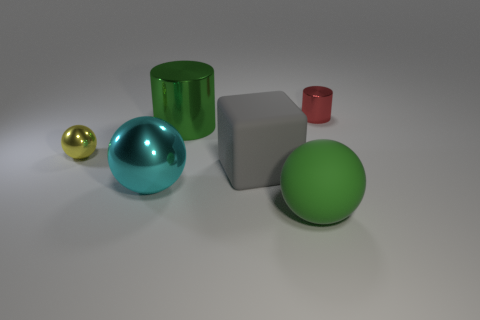Add 3 big cyan metal things. How many objects exist? 9 Subtract all cubes. How many objects are left? 5 Subtract all yellow metal cylinders. Subtract all big cyan metal balls. How many objects are left? 5 Add 4 blocks. How many blocks are left? 5 Add 6 large brown things. How many large brown things exist? 6 Subtract 0 gray spheres. How many objects are left? 6 